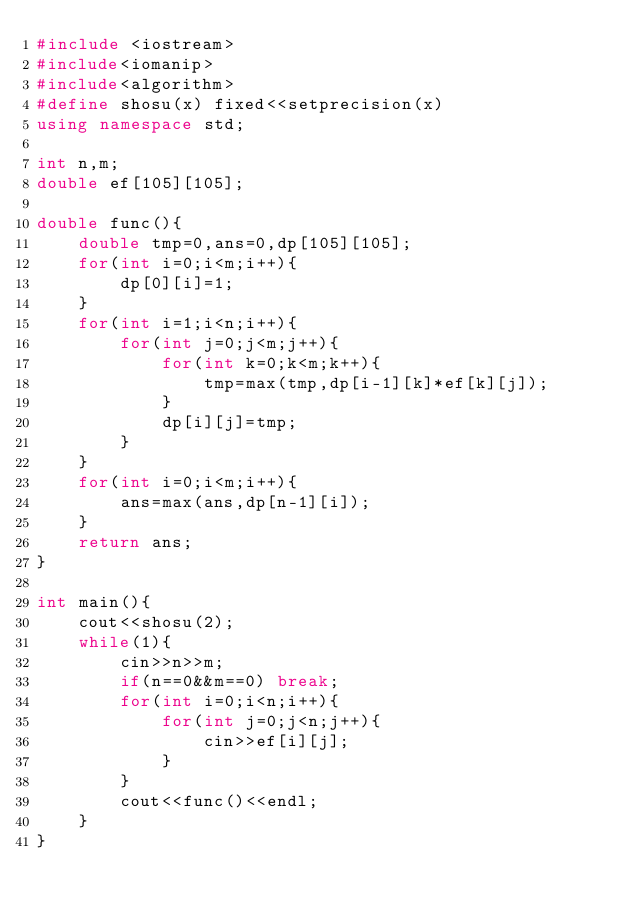<code> <loc_0><loc_0><loc_500><loc_500><_C++_>#include <iostream>
#include<iomanip>
#include<algorithm>
#define shosu(x) fixed<<setprecision(x)
using namespace std;

int n,m;
double ef[105][105];

double func(){
	double tmp=0,ans=0,dp[105][105];
	for(int i=0;i<m;i++){
		dp[0][i]=1;
	}
	for(int i=1;i<n;i++){
		for(int j=0;j<m;j++){
			for(int k=0;k<m;k++){
				tmp=max(tmp,dp[i-1][k]*ef[k][j]);
			}
			dp[i][j]=tmp;
		}
	}
	for(int i=0;i<m;i++){
		ans=max(ans,dp[n-1][i]);
	}
	return ans;
}

int main(){
	cout<<shosu(2);
	while(1){
		cin>>n>>m;
		if(n==0&&m==0) break;
		for(int i=0;i<n;i++){
			for(int j=0;j<n;j++){
				cin>>ef[i][j];
			}
		}
		cout<<func()<<endl;
	}
}</code> 